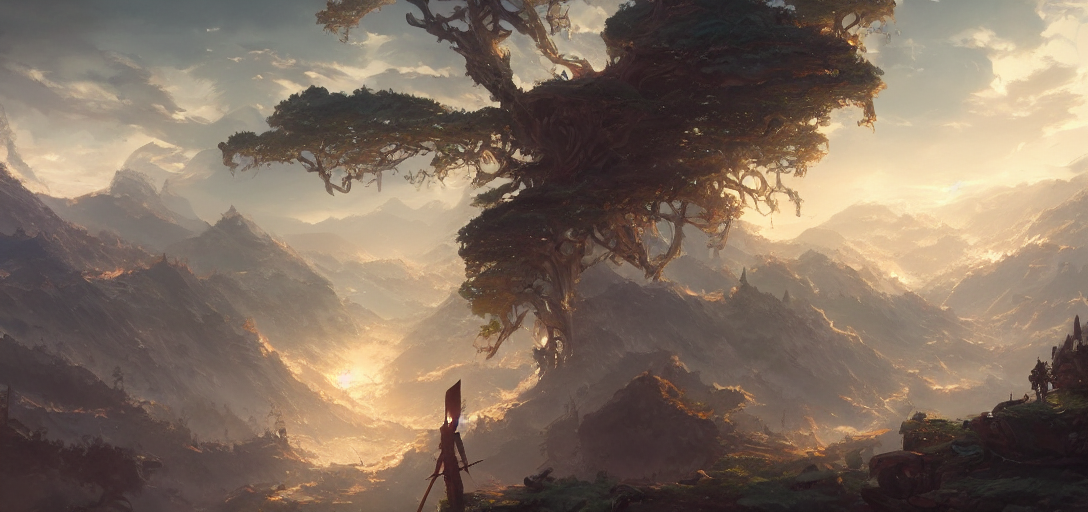What time of day does this image depict? The image captures a scene that suggests sunrise or sunset, as indicated by the warm and soft lighting that graces the landscape. 